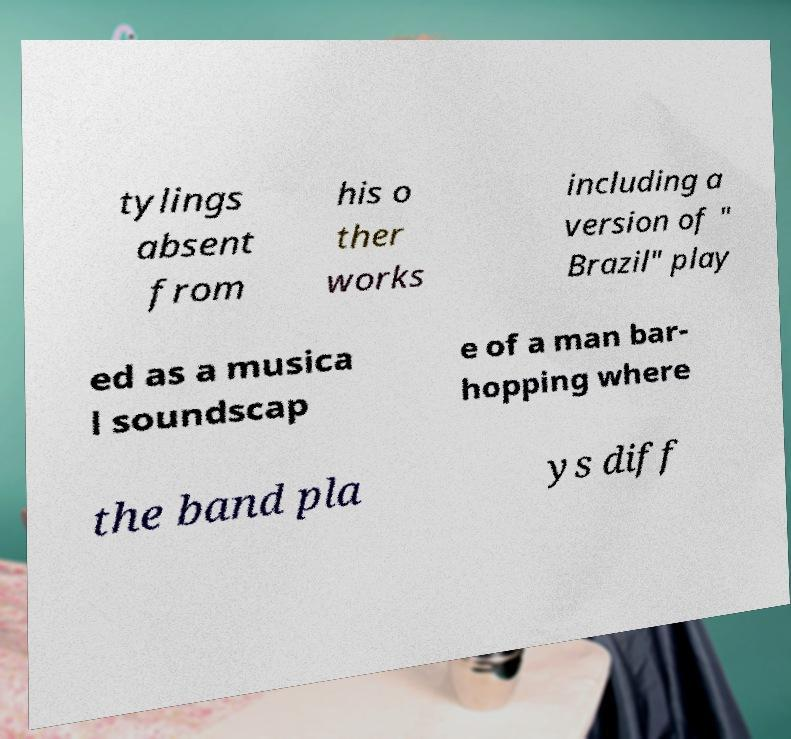Can you accurately transcribe the text from the provided image for me? tylings absent from his o ther works including a version of " Brazil" play ed as a musica l soundscap e of a man bar- hopping where the band pla ys diff 